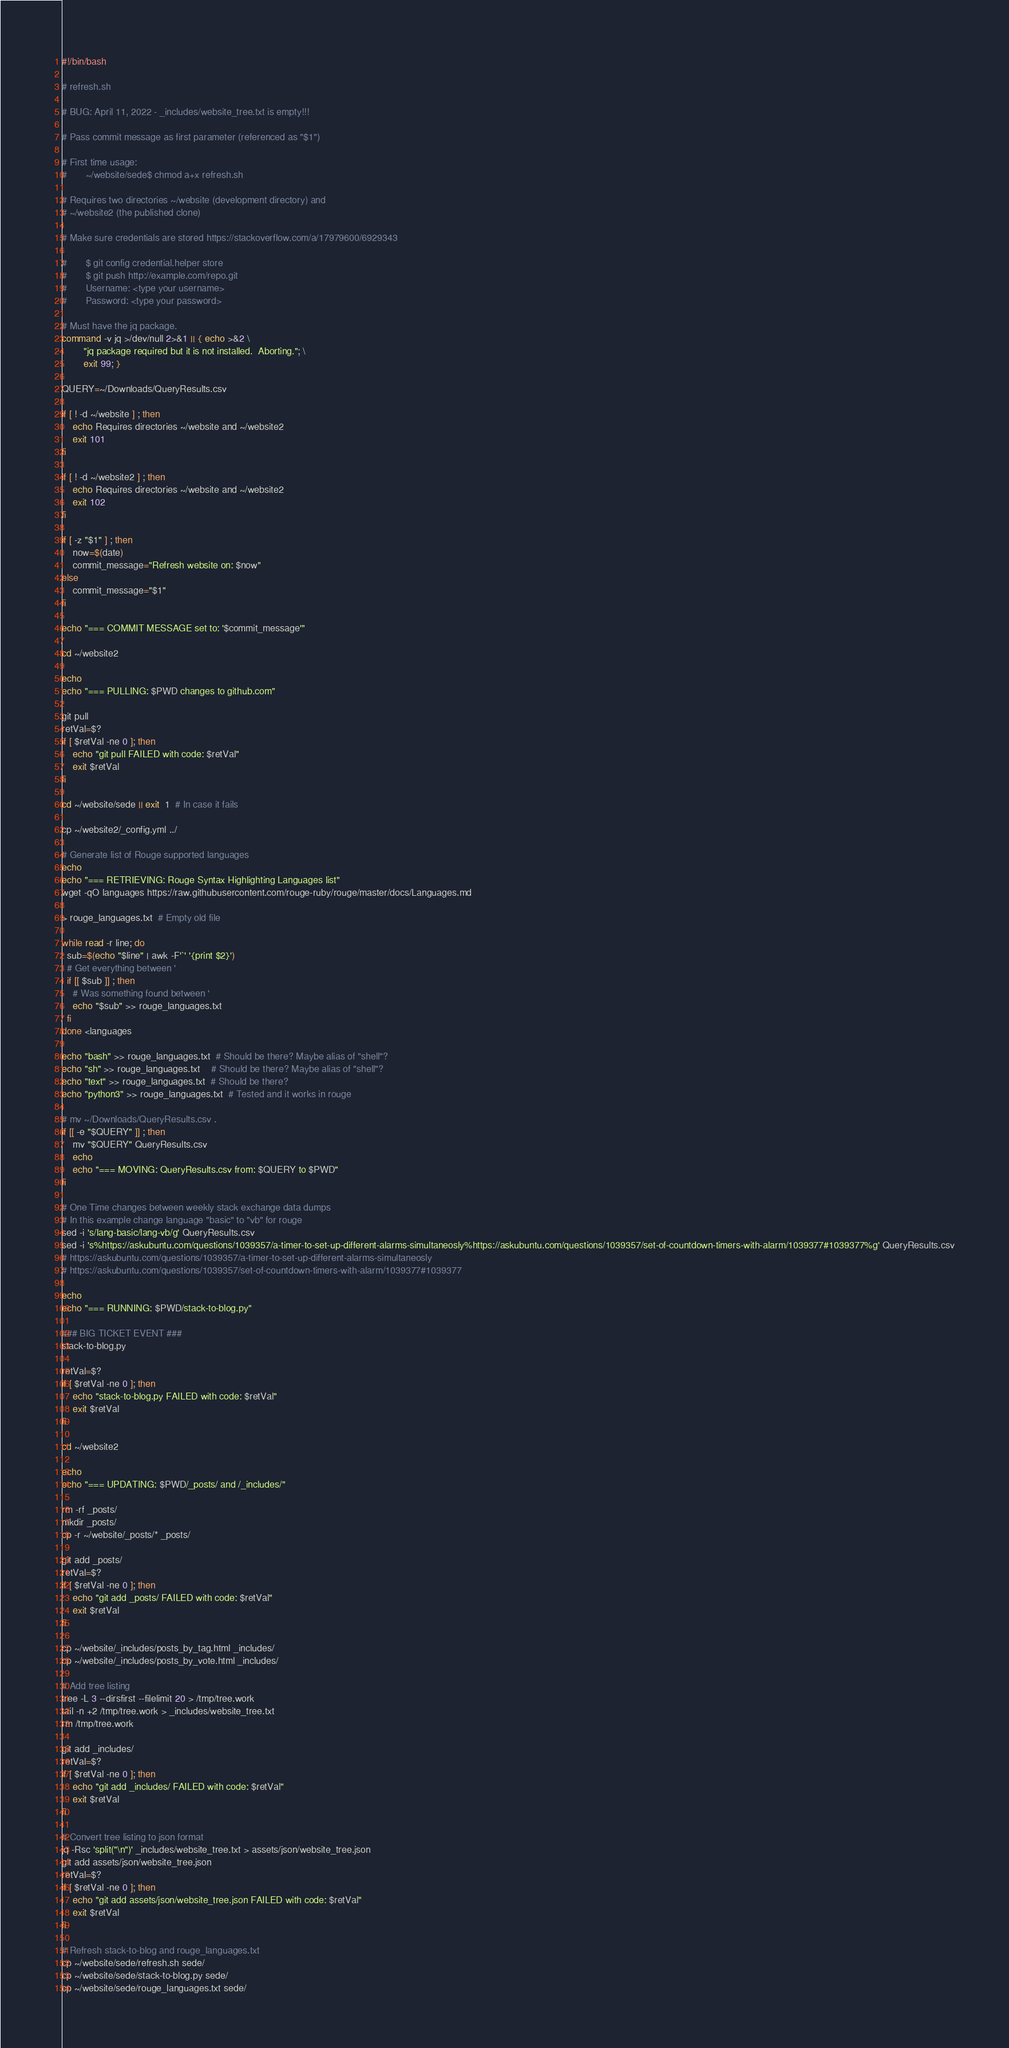Convert code to text. <code><loc_0><loc_0><loc_500><loc_500><_Bash_>#!/bin/bash

# refresh.sh

# BUG: April 11, 2022 - _includes/website_tree.txt is empty!!!

# Pass commit message as first parameter (referenced as "$1")

# First time usage:
#       ~/website/sede$ chmod a+x refresh.sh

# Requires two directories ~/website (development directory) and
# ~/website2 (the published clone)

# Make sure credentials are stored https://stackoverflow.com/a/17979600/6929343

#       $ git config credential.helper store
#       $ git push http://example.com/repo.git
#       Username: <type your username>
#       Password: <type your password>

# Must have the jq package.
command -v jq >/dev/null 2>&1 || { echo >&2 \
        "jq package required but it is not installed.  Aborting."; \
        exit 99; }

QUERY=~/Downloads/QueryResults.csv

if [ ! -d ~/website ] ; then 
    echo Requires directories ~/website and ~/website2
    exit 101
fi

if [ ! -d ~/website2 ] ; then 
    echo Requires directories ~/website and ~/website2
    exit 102
fi

if [ -z "$1" ] ; then
    now=$(date)
    commit_message="Refresh website on: $now"
else
    commit_message="$1"
fi

echo "=== COMMIT MESSAGE set to: '$commit_message'"

cd ~/website2

echo
echo "=== PULLING: $PWD changes to github.com"

git pull
retVal=$?
if [ $retVal -ne 0 ]; then
    echo "git pull FAILED with code: $retVal"
    exit $retVal
fi

cd ~/website/sede || exit  1  # In case it fails

cp ~/website2/_config.yml ../

# Generate list of Rouge supported languages
echo
echo "=== RETRIEVING: Rouge Syntax Highlighting Languages list"
wget -qO languages https://raw.githubusercontent.com/rouge-ruby/rouge/master/docs/Languages.md

> rouge_languages.txt  # Empty old file

while read -r line; do
  sub=$(echo "$line" | awk -F'`' '{print $2}')
  # Get everything between '
  if [[ $sub ]] ; then
    # Was something found between '
    echo "$sub" >> rouge_languages.txt
  fi
done <languages

echo "bash" >> rouge_languages.txt  # Should be there? Maybe alias of "shell"?
echo "sh" >> rouge_languages.txt    # Should be there? Maybe alias of "shell"?
echo "text" >> rouge_languages.txt  # Should be there?
echo "python3" >> rouge_languages.txt  # Tested and it works in rouge

# mv ~/Downloads/QueryResults.csv .
if [[ -e "$QUERY" ]] ; then
    mv "$QUERY" QueryResults.csv
    echo
    echo "=== MOVING: QueryResults.csv from: $QUERY to $PWD"
fi

# One Time changes between weekly stack exchange data dumps
# In this example change language "basic" to "vb" for rouge
sed -i 's/lang-basic/lang-vb/g' QueryResults.csv
sed -i 's%https://askubuntu.com/questions/1039357/a-timer-to-set-up-different-alarms-simultaneosly%https://askubuntu.com/questions/1039357/set-of-countdown-timers-with-alarm/1039377#1039377%g' QueryResults.csv
# https://askubuntu.com/questions/1039357/a-timer-to-set-up-different-alarms-simultaneosly
# https://askubuntu.com/questions/1039357/set-of-countdown-timers-with-alarm/1039377#1039377

echo
echo "=== RUNNING: $PWD/stack-to-blog.py"

### BIG TICKET EVENT ###
stack-to-blog.py

retVal=$?
if [ $retVal -ne 0 ]; then
    echo "stack-to-blog.py FAILED with code: $retVal"
    exit $retVal
fi

cd ~/website2

echo
echo "=== UPDATING: $PWD/_posts/ and /_includes/"

rm -rf _posts/
mkdir _posts/
cp -r ~/website/_posts/* _posts/

git add _posts/
retVal=$?
if [ $retVal -ne 0 ]; then
    echo "git add _posts/ FAILED with code: $retVal"
    exit $retVal
fi

cp ~/website/_includes/posts_by_tag.html _includes/
cp ~/website/_includes/posts_by_vote.html _includes/

# Add tree listing
tree -L 3 --dirsfirst --filelimit 20 > /tmp/tree.work
tail -n +2 /tmp/tree.work > _includes/website_tree.txt
rm /tmp/tree.work

git add _includes/
retVal=$?
if [ $retVal -ne 0 ]; then
    echo "git add _includes/ FAILED with code: $retVal"
    exit $retVal
fi

# Convert tree listing to json format
jq -Rsc 'split("\n")' _includes/website_tree.txt > assets/json/website_tree.json
git add assets/json/website_tree.json
retVal=$?
if [ $retVal -ne 0 ]; then
    echo "git add assets/json/website_tree.json FAILED with code: $retVal"
    exit $retVal
fi

# Refresh stack-to-blog and rouge_languages.txt
cp ~/website/sede/refresh.sh sede/
cp ~/website/sede/stack-to-blog.py sede/
cp ~/website/sede/rouge_languages.txt sede/</code> 